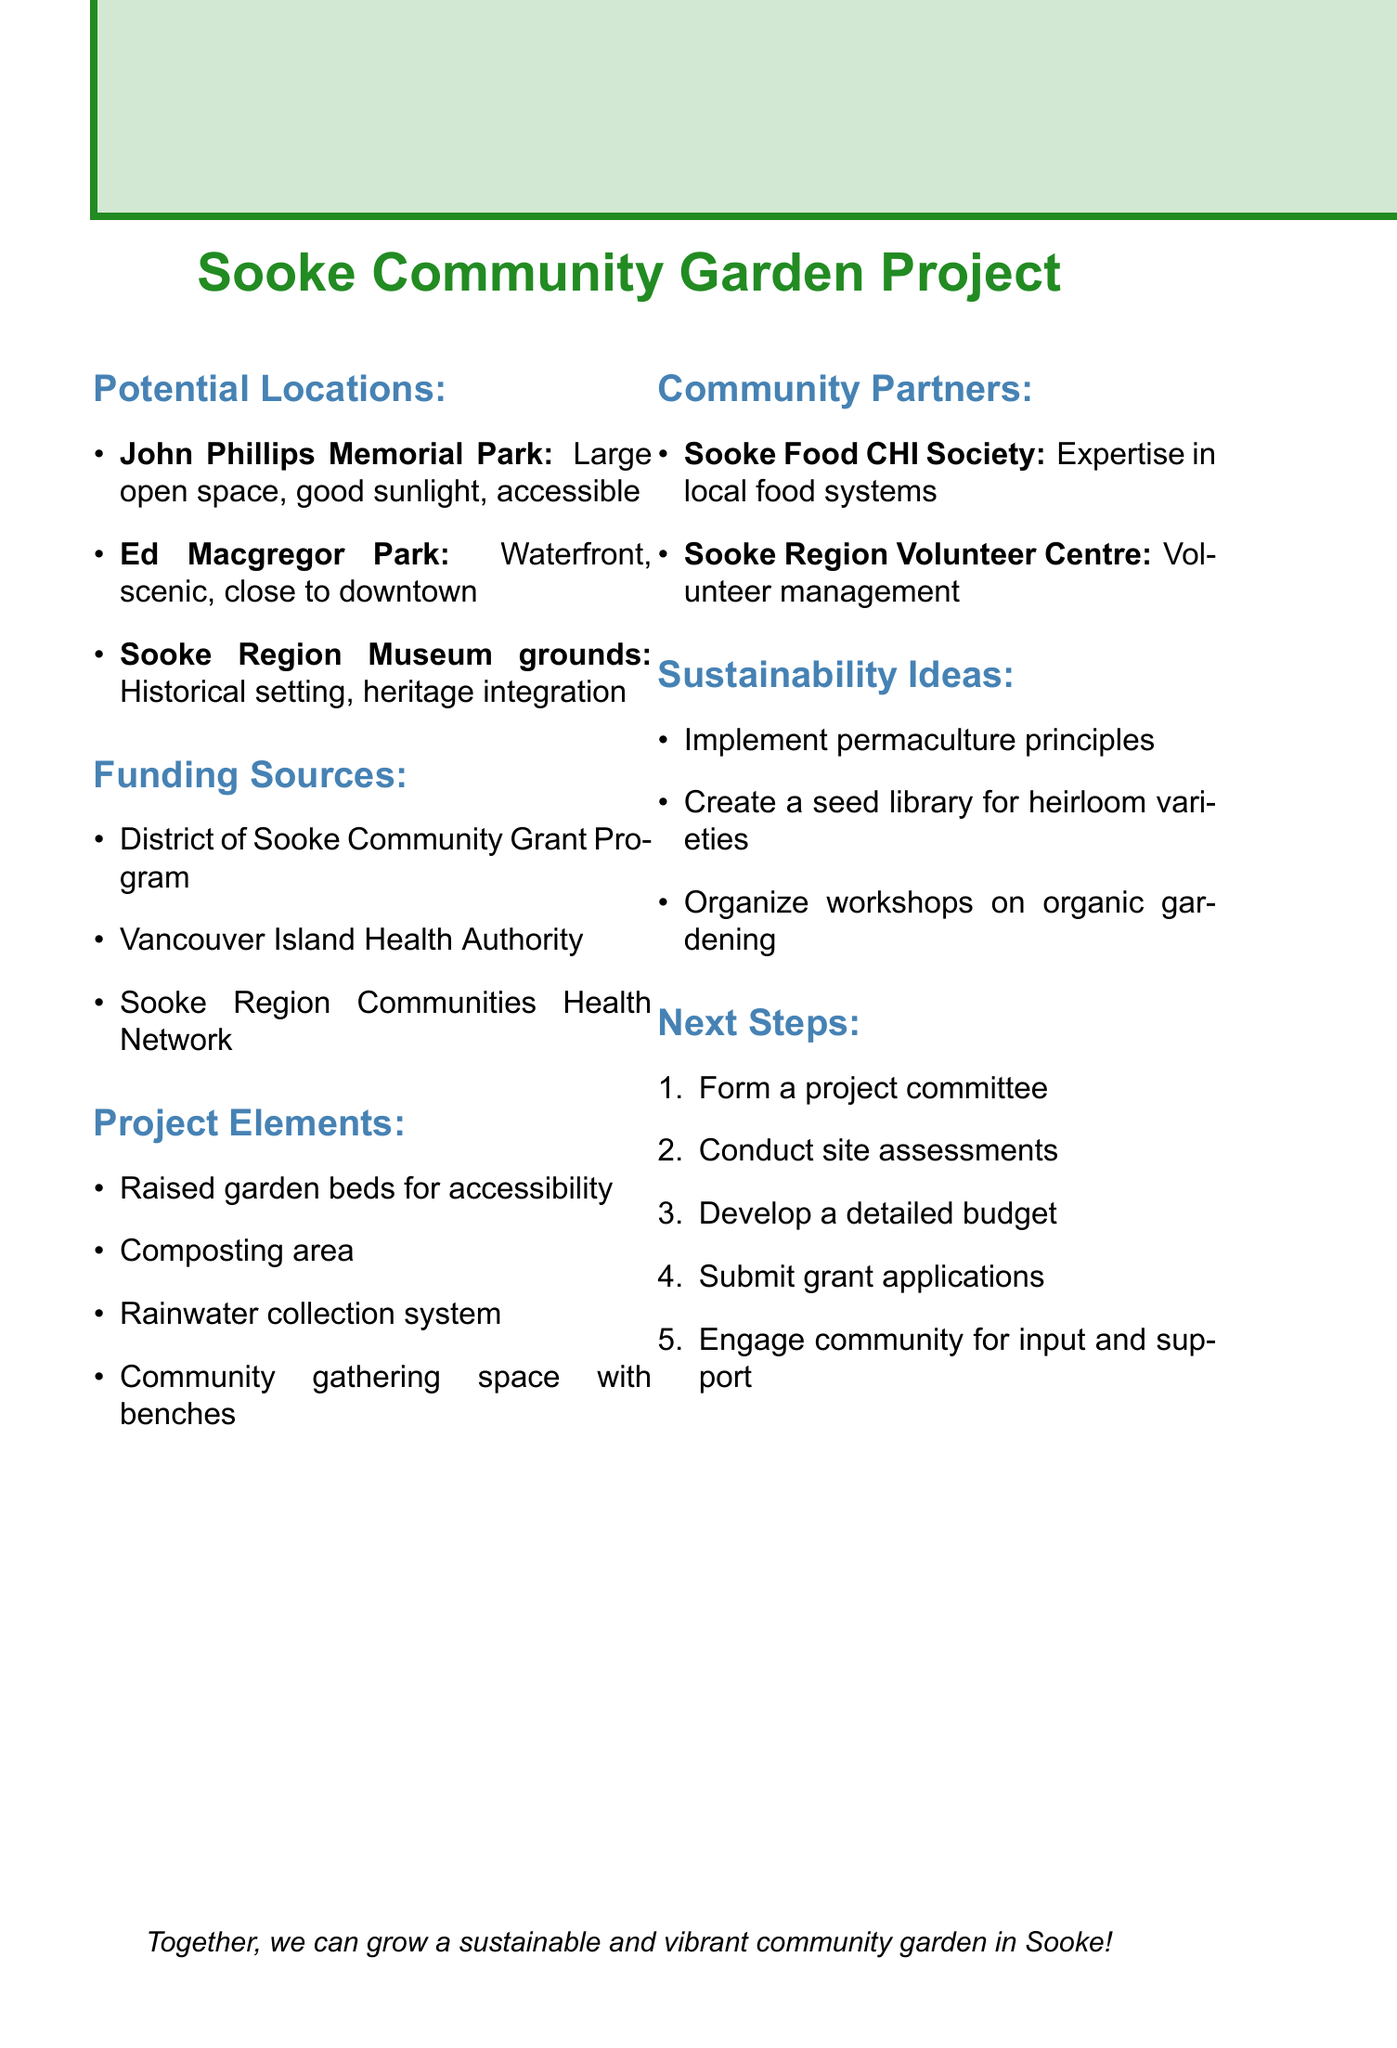What is one potential location for the garden? The document lists several locations, one of them being John Phillips Memorial Park.
Answer: John Phillips Memorial Park What funding source is specifically for health-promoting initiatives? The document states that Vancouver Island Health Authority offers grants for health-promoting community initiatives.
Answer: Vancouver Island Health Authority What type of garden bed is mentioned for accessibility? The project elements include raised garden beds specifically designed for accessibility.
Answer: Raised garden beds Who can provide expertise in local food systems? According to the document, Sooke Food CHI Society can provide expertise in local food systems.
Answer: Sooke Food CHI Society What is one sustainability idea mentioned? The document includes several sustainability ideas, one being the implementation of permaculture principles.
Answer: Implement permaculture principles How many funding sources are listed in the document? The document lists three funding sources for the community garden project.
Answer: Three Which park offers a scenic waterfront location? The document specifies that Ed Macgregor Park offers a scenic waterfront location.
Answer: Ed Macgregor Park What should be formed as a next step in the project? The document suggests forming a project committee as one of the next steps.
Answer: Project committee 